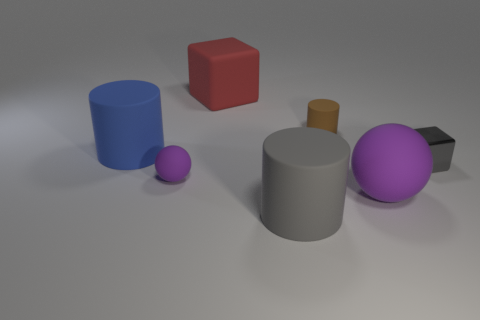Subtract all big cylinders. How many cylinders are left? 1 Subtract all brown cylinders. How many cylinders are left? 2 Add 1 metal things. How many objects exist? 8 Subtract all blue blocks. How many brown cylinders are left? 1 Subtract all cylinders. How many objects are left? 4 Subtract 3 cylinders. How many cylinders are left? 0 Subtract all green balls. Subtract all brown cylinders. How many balls are left? 2 Subtract all small gray metal things. Subtract all big gray cylinders. How many objects are left? 5 Add 2 tiny gray objects. How many tiny gray objects are left? 3 Add 6 big red blocks. How many big red blocks exist? 7 